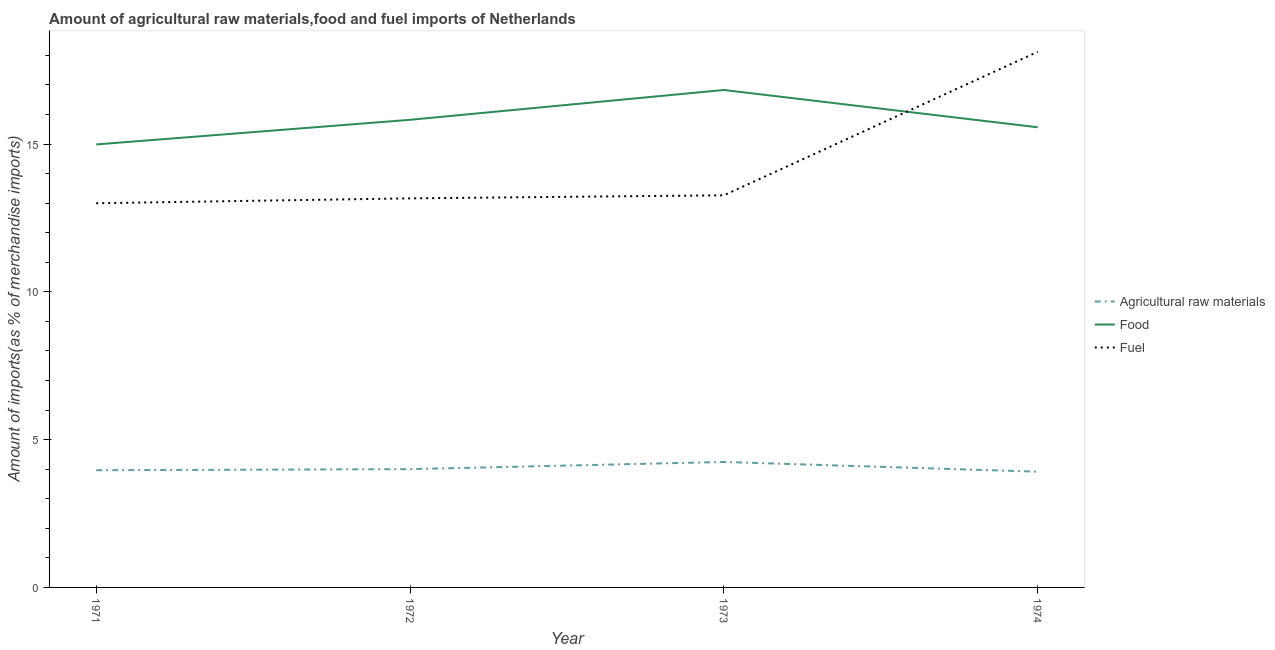Does the line corresponding to percentage of raw materials imports intersect with the line corresponding to percentage of fuel imports?
Keep it short and to the point. No. Is the number of lines equal to the number of legend labels?
Provide a short and direct response. Yes. What is the percentage of fuel imports in 1971?
Provide a succinct answer. 13. Across all years, what is the maximum percentage of fuel imports?
Provide a short and direct response. 18.12. Across all years, what is the minimum percentage of raw materials imports?
Your answer should be very brief. 3.92. In which year was the percentage of raw materials imports maximum?
Your answer should be compact. 1973. In which year was the percentage of raw materials imports minimum?
Make the answer very short. 1974. What is the total percentage of fuel imports in the graph?
Provide a succinct answer. 57.54. What is the difference between the percentage of raw materials imports in 1972 and that in 1974?
Ensure brevity in your answer.  0.09. What is the difference between the percentage of fuel imports in 1971 and the percentage of raw materials imports in 1972?
Offer a very short reply. 9. What is the average percentage of raw materials imports per year?
Offer a very short reply. 4.03. In the year 1972, what is the difference between the percentage of fuel imports and percentage of food imports?
Provide a succinct answer. -2.66. What is the ratio of the percentage of raw materials imports in 1972 to that in 1974?
Keep it short and to the point. 1.02. Is the percentage of fuel imports in 1971 less than that in 1973?
Your answer should be very brief. Yes. Is the difference between the percentage of raw materials imports in 1972 and 1974 greater than the difference between the percentage of fuel imports in 1972 and 1974?
Ensure brevity in your answer.  Yes. What is the difference between the highest and the second highest percentage of food imports?
Ensure brevity in your answer.  1.01. What is the difference between the highest and the lowest percentage of raw materials imports?
Provide a short and direct response. 0.33. In how many years, is the percentage of food imports greater than the average percentage of food imports taken over all years?
Make the answer very short. 2. How many years are there in the graph?
Provide a succinct answer. 4. Are the values on the major ticks of Y-axis written in scientific E-notation?
Ensure brevity in your answer.  No. Does the graph contain any zero values?
Provide a short and direct response. No. How are the legend labels stacked?
Your answer should be very brief. Vertical. What is the title of the graph?
Your answer should be very brief. Amount of agricultural raw materials,food and fuel imports of Netherlands. Does "Fuel" appear as one of the legend labels in the graph?
Make the answer very short. Yes. What is the label or title of the Y-axis?
Keep it short and to the point. Amount of imports(as % of merchandise imports). What is the Amount of imports(as % of merchandise imports) in Agricultural raw materials in 1971?
Your response must be concise. 3.96. What is the Amount of imports(as % of merchandise imports) of Food in 1971?
Keep it short and to the point. 14.99. What is the Amount of imports(as % of merchandise imports) in Fuel in 1971?
Provide a short and direct response. 13. What is the Amount of imports(as % of merchandise imports) in Agricultural raw materials in 1972?
Provide a succinct answer. 4. What is the Amount of imports(as % of merchandise imports) of Food in 1972?
Ensure brevity in your answer.  15.82. What is the Amount of imports(as % of merchandise imports) in Fuel in 1972?
Offer a very short reply. 13.16. What is the Amount of imports(as % of merchandise imports) in Agricultural raw materials in 1973?
Provide a short and direct response. 4.24. What is the Amount of imports(as % of merchandise imports) in Food in 1973?
Your answer should be very brief. 16.83. What is the Amount of imports(as % of merchandise imports) in Fuel in 1973?
Your response must be concise. 13.27. What is the Amount of imports(as % of merchandise imports) of Agricultural raw materials in 1974?
Provide a short and direct response. 3.92. What is the Amount of imports(as % of merchandise imports) in Food in 1974?
Offer a terse response. 15.57. What is the Amount of imports(as % of merchandise imports) in Fuel in 1974?
Offer a terse response. 18.12. Across all years, what is the maximum Amount of imports(as % of merchandise imports) in Agricultural raw materials?
Provide a succinct answer. 4.24. Across all years, what is the maximum Amount of imports(as % of merchandise imports) of Food?
Provide a short and direct response. 16.83. Across all years, what is the maximum Amount of imports(as % of merchandise imports) in Fuel?
Offer a very short reply. 18.12. Across all years, what is the minimum Amount of imports(as % of merchandise imports) in Agricultural raw materials?
Ensure brevity in your answer.  3.92. Across all years, what is the minimum Amount of imports(as % of merchandise imports) in Food?
Your answer should be very brief. 14.99. Across all years, what is the minimum Amount of imports(as % of merchandise imports) in Fuel?
Provide a succinct answer. 13. What is the total Amount of imports(as % of merchandise imports) in Agricultural raw materials in the graph?
Keep it short and to the point. 16.13. What is the total Amount of imports(as % of merchandise imports) in Food in the graph?
Your answer should be very brief. 63.2. What is the total Amount of imports(as % of merchandise imports) in Fuel in the graph?
Keep it short and to the point. 57.54. What is the difference between the Amount of imports(as % of merchandise imports) of Agricultural raw materials in 1971 and that in 1972?
Give a very brief answer. -0.04. What is the difference between the Amount of imports(as % of merchandise imports) of Food in 1971 and that in 1972?
Provide a succinct answer. -0.83. What is the difference between the Amount of imports(as % of merchandise imports) in Fuel in 1971 and that in 1972?
Your answer should be compact. -0.17. What is the difference between the Amount of imports(as % of merchandise imports) in Agricultural raw materials in 1971 and that in 1973?
Your answer should be very brief. -0.28. What is the difference between the Amount of imports(as % of merchandise imports) of Food in 1971 and that in 1973?
Your response must be concise. -1.84. What is the difference between the Amount of imports(as % of merchandise imports) of Fuel in 1971 and that in 1973?
Give a very brief answer. -0.27. What is the difference between the Amount of imports(as % of merchandise imports) in Agricultural raw materials in 1971 and that in 1974?
Your answer should be very brief. 0.05. What is the difference between the Amount of imports(as % of merchandise imports) in Food in 1971 and that in 1974?
Keep it short and to the point. -0.58. What is the difference between the Amount of imports(as % of merchandise imports) of Fuel in 1971 and that in 1974?
Your answer should be very brief. -5.12. What is the difference between the Amount of imports(as % of merchandise imports) of Agricultural raw materials in 1972 and that in 1973?
Offer a very short reply. -0.24. What is the difference between the Amount of imports(as % of merchandise imports) of Food in 1972 and that in 1973?
Your answer should be very brief. -1.01. What is the difference between the Amount of imports(as % of merchandise imports) of Fuel in 1972 and that in 1973?
Give a very brief answer. -0.1. What is the difference between the Amount of imports(as % of merchandise imports) in Agricultural raw materials in 1972 and that in 1974?
Give a very brief answer. 0.09. What is the difference between the Amount of imports(as % of merchandise imports) in Food in 1972 and that in 1974?
Your answer should be compact. 0.25. What is the difference between the Amount of imports(as % of merchandise imports) of Fuel in 1972 and that in 1974?
Offer a very short reply. -4.96. What is the difference between the Amount of imports(as % of merchandise imports) of Agricultural raw materials in 1973 and that in 1974?
Your response must be concise. 0.33. What is the difference between the Amount of imports(as % of merchandise imports) of Food in 1973 and that in 1974?
Ensure brevity in your answer.  1.26. What is the difference between the Amount of imports(as % of merchandise imports) of Fuel in 1973 and that in 1974?
Make the answer very short. -4.85. What is the difference between the Amount of imports(as % of merchandise imports) in Agricultural raw materials in 1971 and the Amount of imports(as % of merchandise imports) in Food in 1972?
Ensure brevity in your answer.  -11.85. What is the difference between the Amount of imports(as % of merchandise imports) of Agricultural raw materials in 1971 and the Amount of imports(as % of merchandise imports) of Fuel in 1972?
Make the answer very short. -9.2. What is the difference between the Amount of imports(as % of merchandise imports) in Food in 1971 and the Amount of imports(as % of merchandise imports) in Fuel in 1972?
Ensure brevity in your answer.  1.82. What is the difference between the Amount of imports(as % of merchandise imports) in Agricultural raw materials in 1971 and the Amount of imports(as % of merchandise imports) in Food in 1973?
Provide a short and direct response. -12.86. What is the difference between the Amount of imports(as % of merchandise imports) in Agricultural raw materials in 1971 and the Amount of imports(as % of merchandise imports) in Fuel in 1973?
Your response must be concise. -9.3. What is the difference between the Amount of imports(as % of merchandise imports) of Food in 1971 and the Amount of imports(as % of merchandise imports) of Fuel in 1973?
Your answer should be compact. 1.72. What is the difference between the Amount of imports(as % of merchandise imports) of Agricultural raw materials in 1971 and the Amount of imports(as % of merchandise imports) of Food in 1974?
Your answer should be compact. -11.6. What is the difference between the Amount of imports(as % of merchandise imports) in Agricultural raw materials in 1971 and the Amount of imports(as % of merchandise imports) in Fuel in 1974?
Your answer should be very brief. -14.15. What is the difference between the Amount of imports(as % of merchandise imports) of Food in 1971 and the Amount of imports(as % of merchandise imports) of Fuel in 1974?
Your answer should be very brief. -3.13. What is the difference between the Amount of imports(as % of merchandise imports) of Agricultural raw materials in 1972 and the Amount of imports(as % of merchandise imports) of Food in 1973?
Ensure brevity in your answer.  -12.83. What is the difference between the Amount of imports(as % of merchandise imports) in Agricultural raw materials in 1972 and the Amount of imports(as % of merchandise imports) in Fuel in 1973?
Provide a short and direct response. -9.26. What is the difference between the Amount of imports(as % of merchandise imports) in Food in 1972 and the Amount of imports(as % of merchandise imports) in Fuel in 1973?
Give a very brief answer. 2.55. What is the difference between the Amount of imports(as % of merchandise imports) of Agricultural raw materials in 1972 and the Amount of imports(as % of merchandise imports) of Food in 1974?
Offer a terse response. -11.57. What is the difference between the Amount of imports(as % of merchandise imports) of Agricultural raw materials in 1972 and the Amount of imports(as % of merchandise imports) of Fuel in 1974?
Keep it short and to the point. -14.12. What is the difference between the Amount of imports(as % of merchandise imports) in Food in 1972 and the Amount of imports(as % of merchandise imports) in Fuel in 1974?
Your response must be concise. -2.3. What is the difference between the Amount of imports(as % of merchandise imports) in Agricultural raw materials in 1973 and the Amount of imports(as % of merchandise imports) in Food in 1974?
Keep it short and to the point. -11.32. What is the difference between the Amount of imports(as % of merchandise imports) of Agricultural raw materials in 1973 and the Amount of imports(as % of merchandise imports) of Fuel in 1974?
Ensure brevity in your answer.  -13.87. What is the difference between the Amount of imports(as % of merchandise imports) in Food in 1973 and the Amount of imports(as % of merchandise imports) in Fuel in 1974?
Provide a short and direct response. -1.29. What is the average Amount of imports(as % of merchandise imports) in Agricultural raw materials per year?
Your response must be concise. 4.03. What is the average Amount of imports(as % of merchandise imports) in Food per year?
Your answer should be very brief. 15.8. What is the average Amount of imports(as % of merchandise imports) in Fuel per year?
Make the answer very short. 14.39. In the year 1971, what is the difference between the Amount of imports(as % of merchandise imports) of Agricultural raw materials and Amount of imports(as % of merchandise imports) of Food?
Give a very brief answer. -11.02. In the year 1971, what is the difference between the Amount of imports(as % of merchandise imports) of Agricultural raw materials and Amount of imports(as % of merchandise imports) of Fuel?
Make the answer very short. -9.03. In the year 1971, what is the difference between the Amount of imports(as % of merchandise imports) of Food and Amount of imports(as % of merchandise imports) of Fuel?
Ensure brevity in your answer.  1.99. In the year 1972, what is the difference between the Amount of imports(as % of merchandise imports) of Agricultural raw materials and Amount of imports(as % of merchandise imports) of Food?
Your response must be concise. -11.82. In the year 1972, what is the difference between the Amount of imports(as % of merchandise imports) in Agricultural raw materials and Amount of imports(as % of merchandise imports) in Fuel?
Offer a very short reply. -9.16. In the year 1972, what is the difference between the Amount of imports(as % of merchandise imports) in Food and Amount of imports(as % of merchandise imports) in Fuel?
Make the answer very short. 2.66. In the year 1973, what is the difference between the Amount of imports(as % of merchandise imports) of Agricultural raw materials and Amount of imports(as % of merchandise imports) of Food?
Keep it short and to the point. -12.58. In the year 1973, what is the difference between the Amount of imports(as % of merchandise imports) of Agricultural raw materials and Amount of imports(as % of merchandise imports) of Fuel?
Keep it short and to the point. -9.02. In the year 1973, what is the difference between the Amount of imports(as % of merchandise imports) in Food and Amount of imports(as % of merchandise imports) in Fuel?
Your answer should be compact. 3.56. In the year 1974, what is the difference between the Amount of imports(as % of merchandise imports) of Agricultural raw materials and Amount of imports(as % of merchandise imports) of Food?
Your answer should be compact. -11.65. In the year 1974, what is the difference between the Amount of imports(as % of merchandise imports) in Agricultural raw materials and Amount of imports(as % of merchandise imports) in Fuel?
Ensure brevity in your answer.  -14.2. In the year 1974, what is the difference between the Amount of imports(as % of merchandise imports) of Food and Amount of imports(as % of merchandise imports) of Fuel?
Your response must be concise. -2.55. What is the ratio of the Amount of imports(as % of merchandise imports) of Agricultural raw materials in 1971 to that in 1972?
Your answer should be very brief. 0.99. What is the ratio of the Amount of imports(as % of merchandise imports) in Food in 1971 to that in 1972?
Your answer should be very brief. 0.95. What is the ratio of the Amount of imports(as % of merchandise imports) of Fuel in 1971 to that in 1972?
Keep it short and to the point. 0.99. What is the ratio of the Amount of imports(as % of merchandise imports) in Agricultural raw materials in 1971 to that in 1973?
Your response must be concise. 0.93. What is the ratio of the Amount of imports(as % of merchandise imports) of Food in 1971 to that in 1973?
Offer a terse response. 0.89. What is the ratio of the Amount of imports(as % of merchandise imports) of Fuel in 1971 to that in 1973?
Offer a very short reply. 0.98. What is the ratio of the Amount of imports(as % of merchandise imports) in Agricultural raw materials in 1971 to that in 1974?
Your answer should be compact. 1.01. What is the ratio of the Amount of imports(as % of merchandise imports) of Food in 1971 to that in 1974?
Offer a terse response. 0.96. What is the ratio of the Amount of imports(as % of merchandise imports) in Fuel in 1971 to that in 1974?
Give a very brief answer. 0.72. What is the ratio of the Amount of imports(as % of merchandise imports) in Agricultural raw materials in 1972 to that in 1973?
Ensure brevity in your answer.  0.94. What is the ratio of the Amount of imports(as % of merchandise imports) of Food in 1972 to that in 1973?
Your answer should be compact. 0.94. What is the ratio of the Amount of imports(as % of merchandise imports) of Fuel in 1972 to that in 1973?
Offer a terse response. 0.99. What is the ratio of the Amount of imports(as % of merchandise imports) in Food in 1972 to that in 1974?
Offer a very short reply. 1.02. What is the ratio of the Amount of imports(as % of merchandise imports) of Fuel in 1972 to that in 1974?
Provide a short and direct response. 0.73. What is the ratio of the Amount of imports(as % of merchandise imports) in Agricultural raw materials in 1973 to that in 1974?
Provide a short and direct response. 1.08. What is the ratio of the Amount of imports(as % of merchandise imports) in Food in 1973 to that in 1974?
Keep it short and to the point. 1.08. What is the ratio of the Amount of imports(as % of merchandise imports) in Fuel in 1973 to that in 1974?
Your response must be concise. 0.73. What is the difference between the highest and the second highest Amount of imports(as % of merchandise imports) of Agricultural raw materials?
Make the answer very short. 0.24. What is the difference between the highest and the second highest Amount of imports(as % of merchandise imports) of Food?
Your answer should be compact. 1.01. What is the difference between the highest and the second highest Amount of imports(as % of merchandise imports) of Fuel?
Your response must be concise. 4.85. What is the difference between the highest and the lowest Amount of imports(as % of merchandise imports) of Agricultural raw materials?
Give a very brief answer. 0.33. What is the difference between the highest and the lowest Amount of imports(as % of merchandise imports) of Food?
Make the answer very short. 1.84. What is the difference between the highest and the lowest Amount of imports(as % of merchandise imports) of Fuel?
Your answer should be compact. 5.12. 